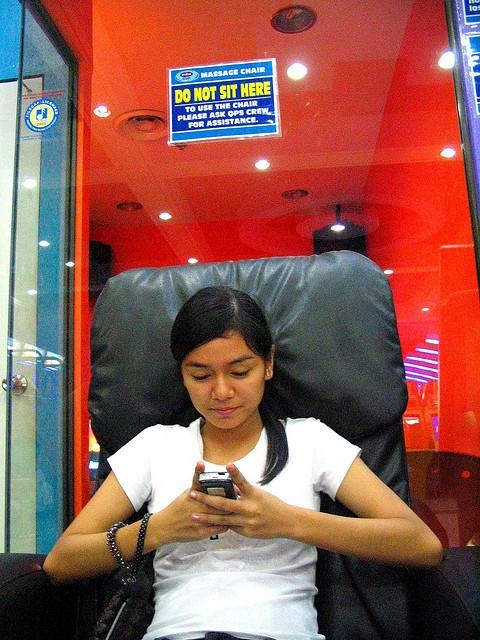What service is this lady receiving?

Choices:
A) nail treatment
B) haircut
C) massage
D) facial treatment massage 